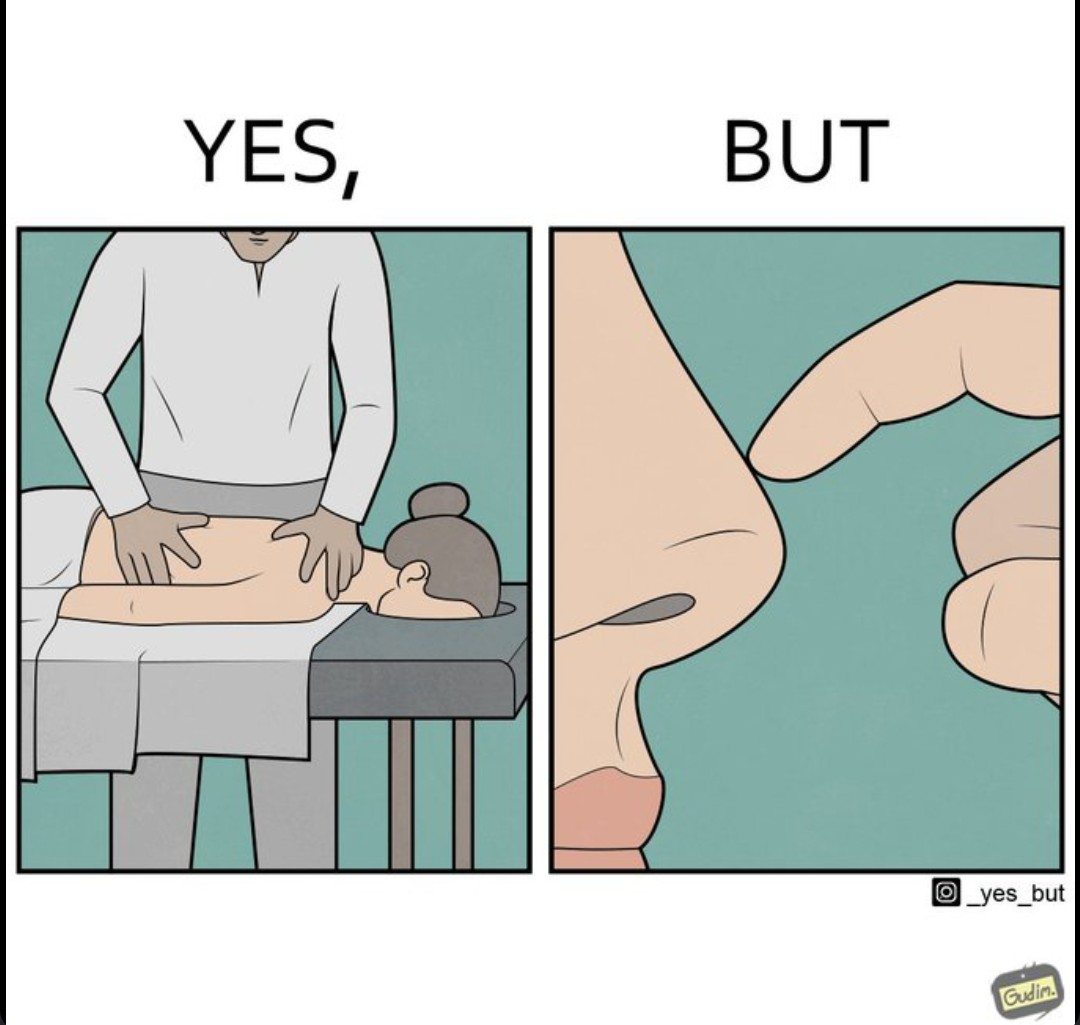Would you classify this image as satirical? Yes, this image is satirical. 